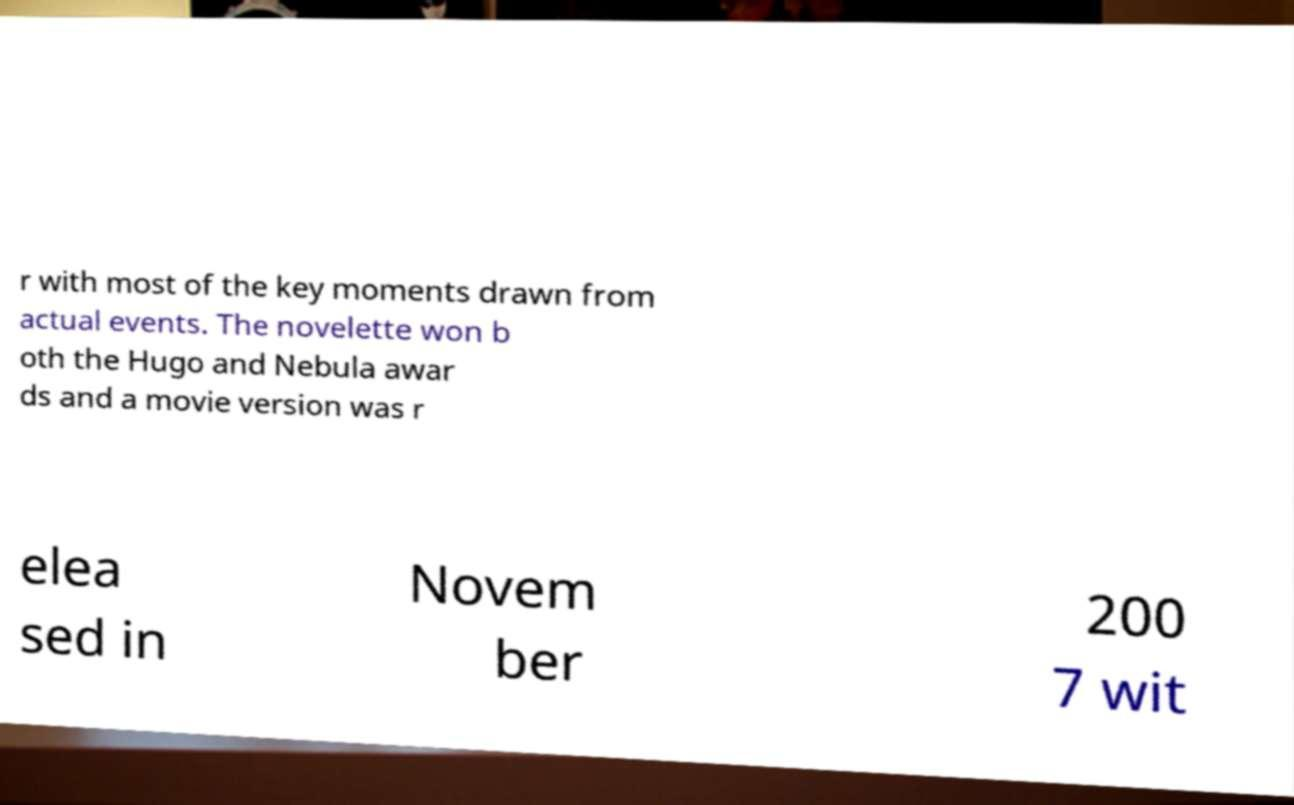Can you accurately transcribe the text from the provided image for me? r with most of the key moments drawn from actual events. The novelette won b oth the Hugo and Nebula awar ds and a movie version was r elea sed in Novem ber 200 7 wit 